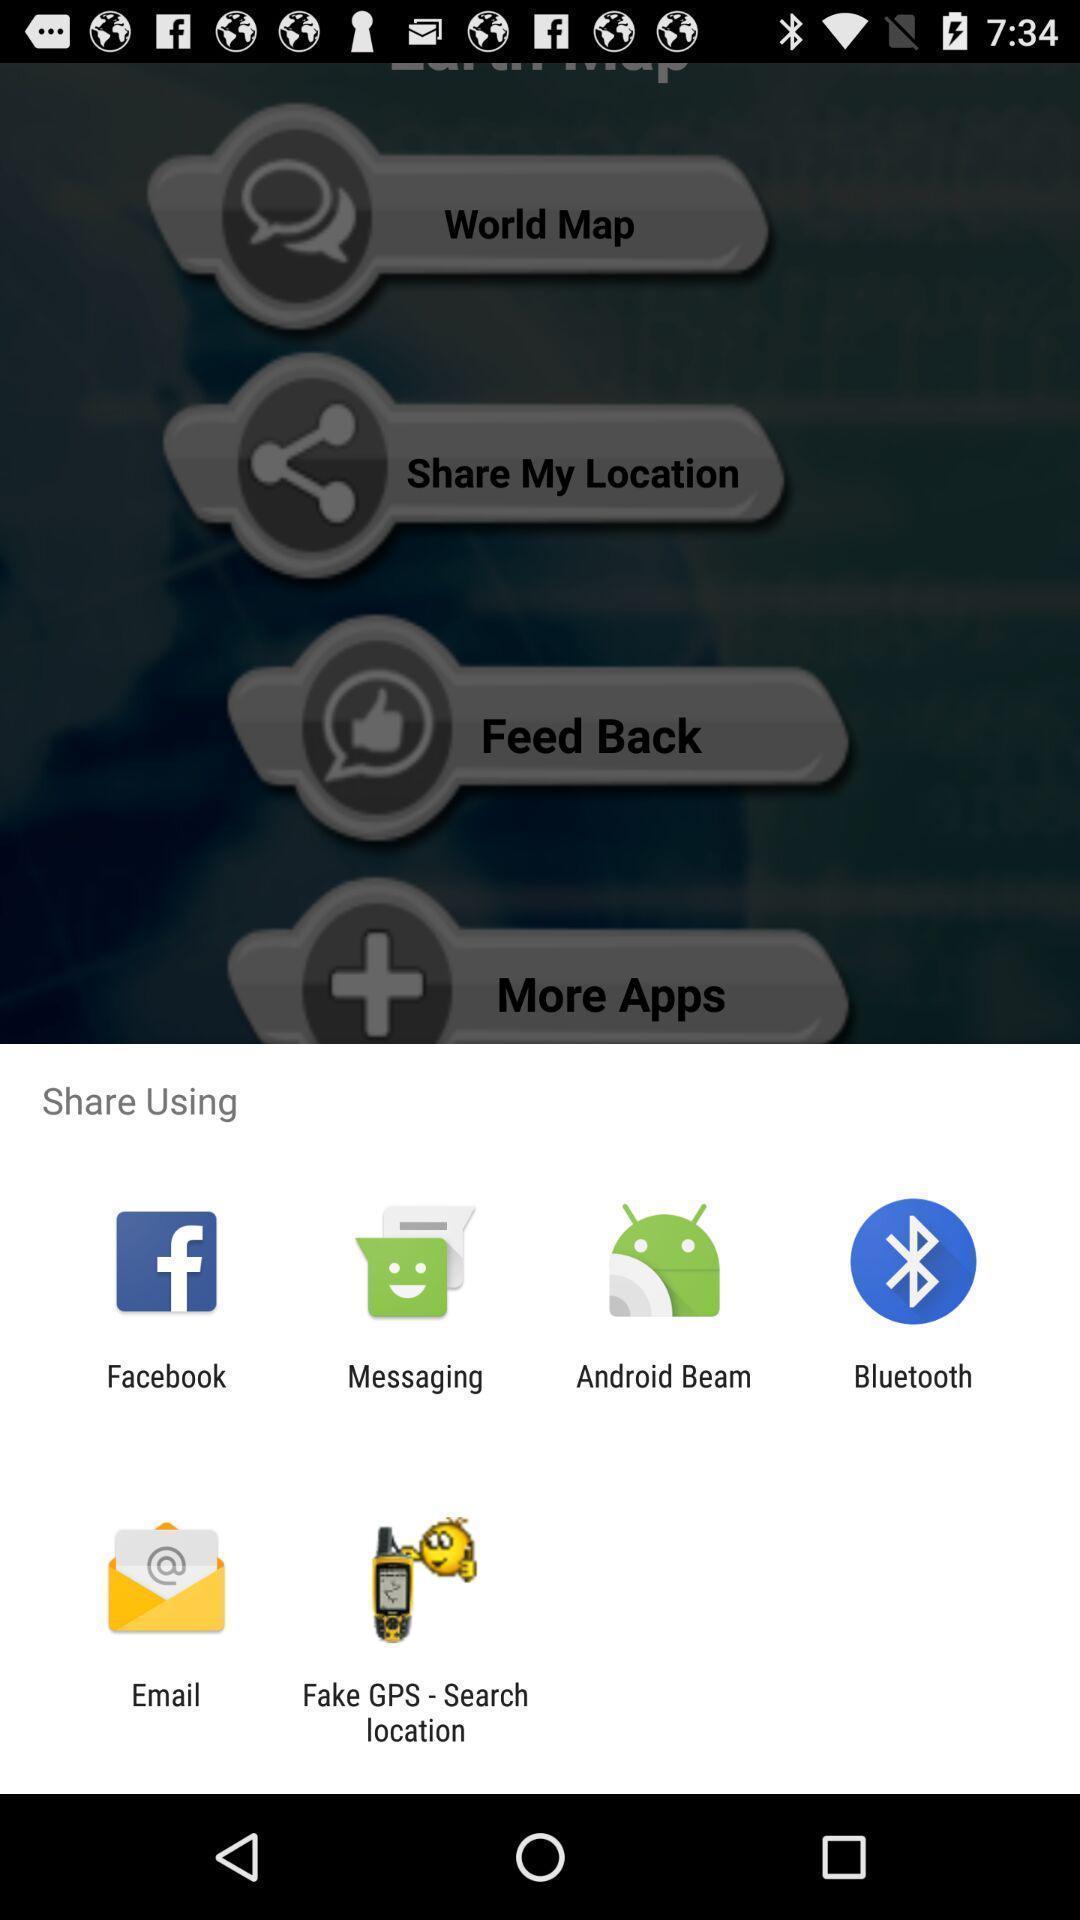Tell me what you see in this picture. Pop-up shows to share using multiple apps. 